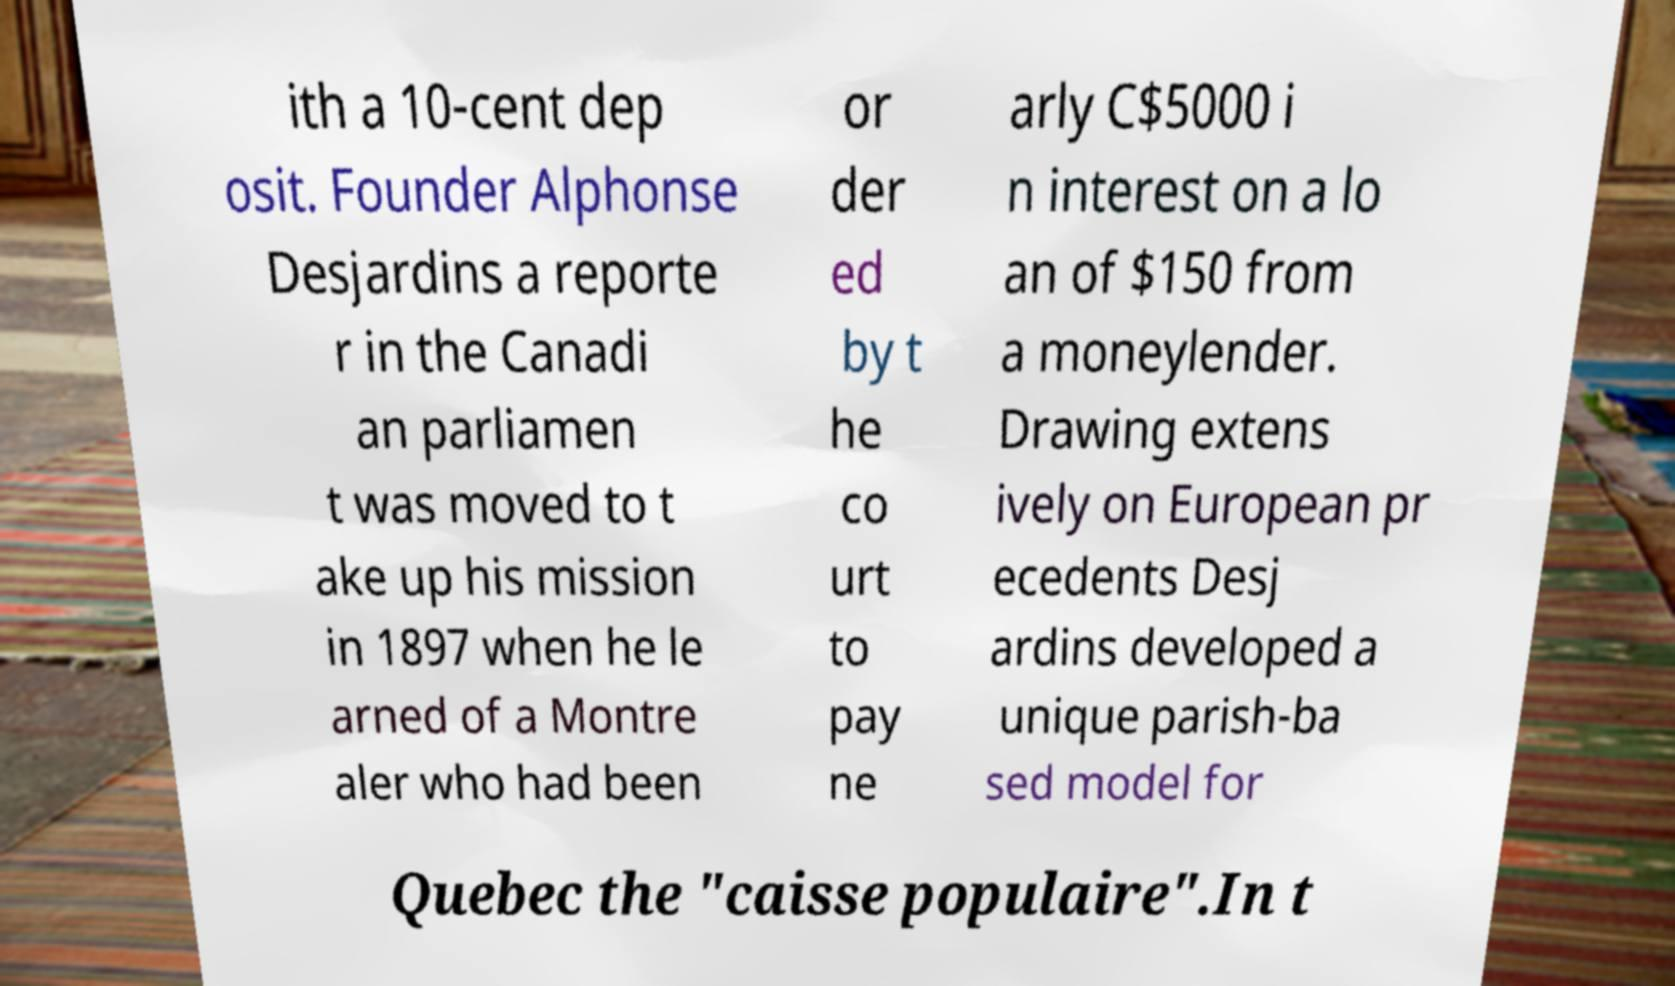Can you read and provide the text displayed in the image?This photo seems to have some interesting text. Can you extract and type it out for me? ith a 10-cent dep osit. Founder Alphonse Desjardins a reporte r in the Canadi an parliamen t was moved to t ake up his mission in 1897 when he le arned of a Montre aler who had been or der ed by t he co urt to pay ne arly C$5000 i n interest on a lo an of $150 from a moneylender. Drawing extens ively on European pr ecedents Desj ardins developed a unique parish-ba sed model for Quebec the "caisse populaire".In t 